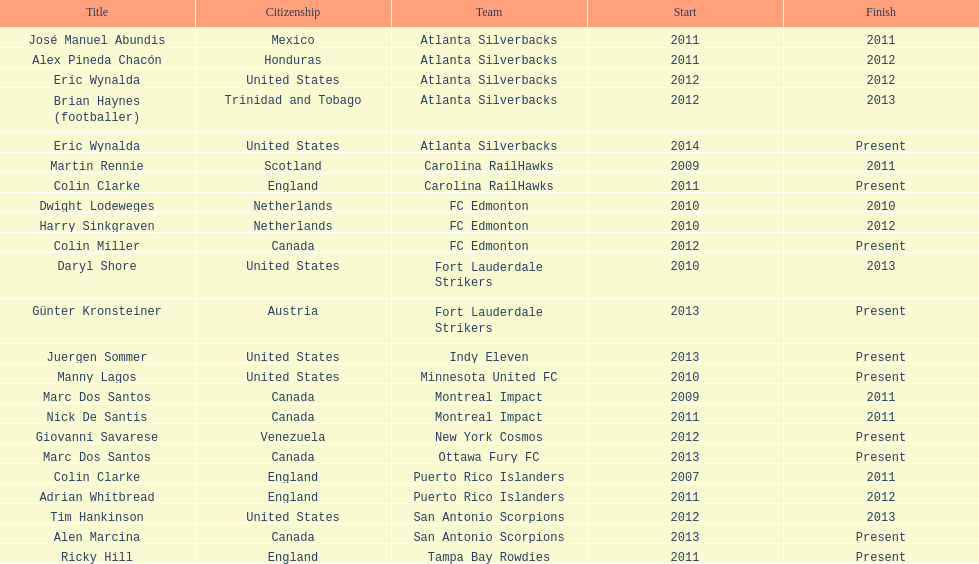Parse the full table. {'header': ['Title', 'Citizenship', 'Team', 'Start', 'Finish'], 'rows': [['José Manuel Abundis', 'Mexico', 'Atlanta Silverbacks', '2011', '2011'], ['Alex Pineda Chacón', 'Honduras', 'Atlanta Silverbacks', '2011', '2012'], ['Eric Wynalda', 'United States', 'Atlanta Silverbacks', '2012', '2012'], ['Brian Haynes (footballer)', 'Trinidad and Tobago', 'Atlanta Silverbacks', '2012', '2013'], ['Eric Wynalda', 'United States', 'Atlanta Silverbacks', '2014', 'Present'], ['Martin Rennie', 'Scotland', 'Carolina RailHawks', '2009', '2011'], ['Colin Clarke', 'England', 'Carolina RailHawks', '2011', 'Present'], ['Dwight Lodeweges', 'Netherlands', 'FC Edmonton', '2010', '2010'], ['Harry Sinkgraven', 'Netherlands', 'FC Edmonton', '2010', '2012'], ['Colin Miller', 'Canada', 'FC Edmonton', '2012', 'Present'], ['Daryl Shore', 'United States', 'Fort Lauderdale Strikers', '2010', '2013'], ['Günter Kronsteiner', 'Austria', 'Fort Lauderdale Strikers', '2013', 'Present'], ['Juergen Sommer', 'United States', 'Indy Eleven', '2013', 'Present'], ['Manny Lagos', 'United States', 'Minnesota United FC', '2010', 'Present'], ['Marc Dos Santos', 'Canada', 'Montreal Impact', '2009', '2011'], ['Nick De Santis', 'Canada', 'Montreal Impact', '2011', '2011'], ['Giovanni Savarese', 'Venezuela', 'New York Cosmos', '2012', 'Present'], ['Marc Dos Santos', 'Canada', 'Ottawa Fury FC', '2013', 'Present'], ['Colin Clarke', 'England', 'Puerto Rico Islanders', '2007', '2011'], ['Adrian Whitbread', 'England', 'Puerto Rico Islanders', '2011', '2012'], ['Tim Hankinson', 'United States', 'San Antonio Scorpions', '2012', '2013'], ['Alen Marcina', 'Canada', 'San Antonio Scorpions', '2013', 'Present'], ['Ricky Hill', 'England', 'Tampa Bay Rowdies', '2011', 'Present']]} Who coached the silverbacks longer, abundis or chacon? Chacon. 